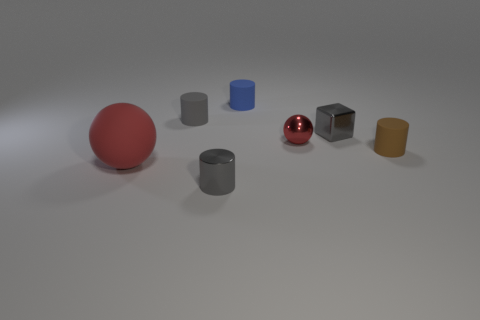There is a gray thing that is in front of the big matte object; does it have the same shape as the tiny brown thing that is in front of the red metal ball?
Provide a succinct answer. Yes. What is the material of the small object that is the same color as the large ball?
Your answer should be compact. Metal. Are there any brown matte objects?
Give a very brief answer. Yes. There is another red thing that is the same shape as the big red rubber object; what is its material?
Provide a short and direct response. Metal. Are there any metallic things to the left of the big sphere?
Offer a very short reply. No. Is the cylinder on the right side of the red metal object made of the same material as the tiny red sphere?
Offer a very short reply. No. Is there a large metallic ball of the same color as the tiny metallic ball?
Ensure brevity in your answer.  No. What is the shape of the tiny blue matte object?
Ensure brevity in your answer.  Cylinder. There is a tiny object in front of the matte cylinder on the right side of the block; what is its color?
Offer a very short reply. Gray. How big is the cylinder that is to the left of the gray metallic cylinder?
Provide a short and direct response. Small. 